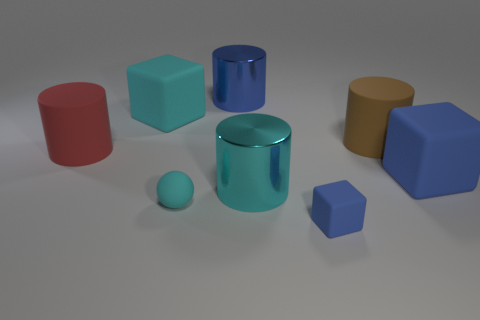What is the cyan cylinder made of?
Provide a succinct answer. Metal. How many cylinders are either tiny matte things or large blue metal objects?
Your answer should be compact. 1. Do the big cyan cylinder and the red thing have the same material?
Your answer should be compact. No. What is the size of the other rubber object that is the same shape as the large brown thing?
Keep it short and to the point. Large. What material is the big thing that is both to the right of the tiny cyan rubber sphere and behind the brown object?
Provide a succinct answer. Metal. Are there the same number of brown cylinders that are on the left side of the tiny cyan rubber sphere and big yellow shiny spheres?
Provide a succinct answer. Yes. How many things are either large objects right of the big blue metal thing or red cylinders?
Make the answer very short. 4. Do the matte cube left of the cyan matte ball and the sphere have the same color?
Your response must be concise. Yes. There is a cyan rubber object that is behind the red matte cylinder; how big is it?
Ensure brevity in your answer.  Large. What is the shape of the tiny thing that is to the left of the large metallic object that is to the right of the large blue shiny thing?
Offer a terse response. Sphere. 